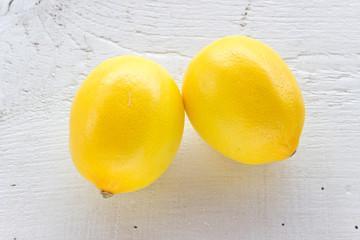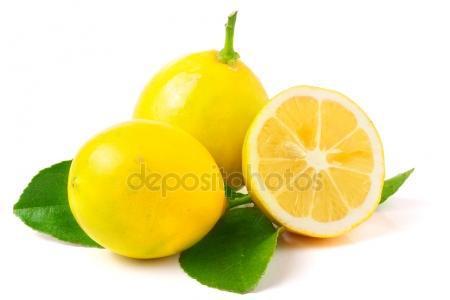The first image is the image on the left, the second image is the image on the right. Assess this claim about the two images: "The left image contain only two whole lemons.". Correct or not? Answer yes or no. Yes. The first image is the image on the left, the second image is the image on the right. For the images displayed, is the sentence "An image contains exactly one whole lemon next to a lemon that is cut in half, and no green leaves are present." factually correct? Answer yes or no. No. 